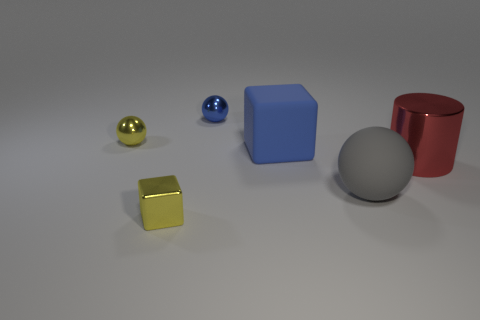Add 1 big matte spheres. How many objects exist? 7 Subtract all blocks. How many objects are left? 4 Subtract all large purple matte blocks. Subtract all shiny cylinders. How many objects are left? 5 Add 3 big rubber spheres. How many big rubber spheres are left? 4 Add 5 metal things. How many metal things exist? 9 Subtract 0 gray cylinders. How many objects are left? 6 